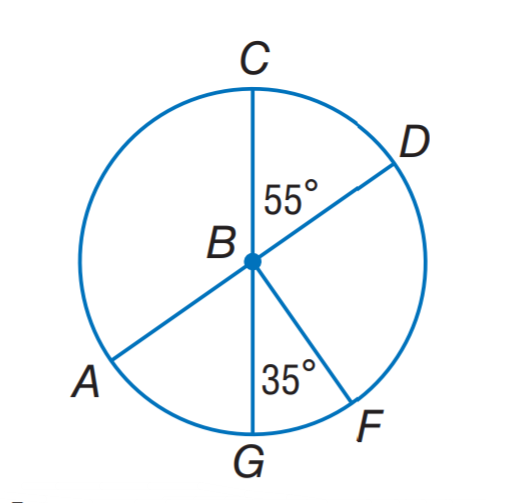Answer the mathemtical geometry problem and directly provide the correct option letter.
Question: A D and C G are diameters of \odot B. Find m \widehat G C F.
Choices: A: 35 B: 295 C: 305 D: 325 D 